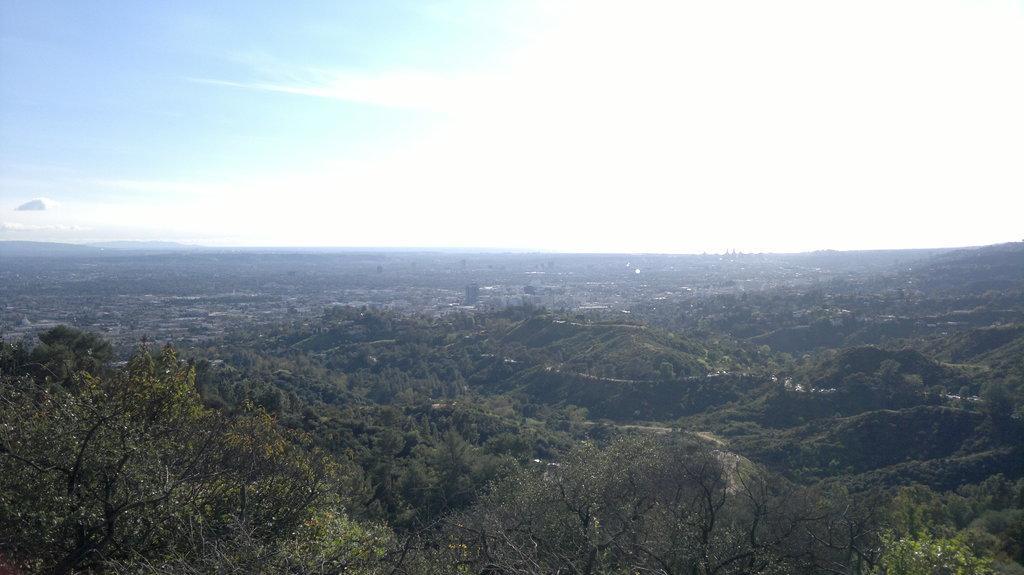Can you describe this image briefly? As we can see in the image there are trees, buildings, sky and clouds. 